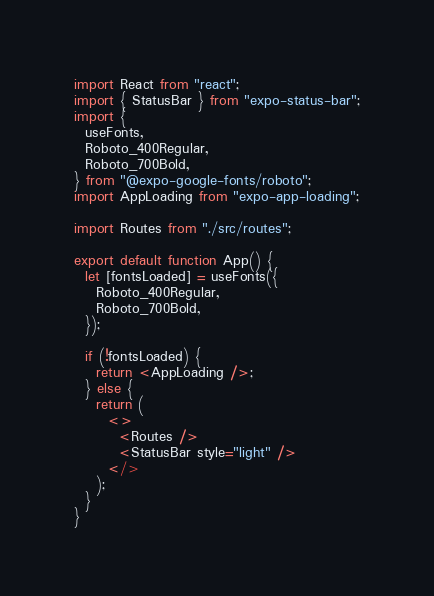<code> <loc_0><loc_0><loc_500><loc_500><_JavaScript_>import React from "react";
import { StatusBar } from "expo-status-bar";
import {
  useFonts,
  Roboto_400Regular,
  Roboto_700Bold,
} from "@expo-google-fonts/roboto";
import AppLoading from "expo-app-loading";

import Routes from "./src/routes";

export default function App() {
  let [fontsLoaded] = useFonts({
    Roboto_400Regular,
    Roboto_700Bold,
  });

  if (!fontsLoaded) {
    return <AppLoading />;
  } else {
    return (
      <>
        <Routes />
        <StatusBar style="light" />
      </>
    );
  }
}
</code> 